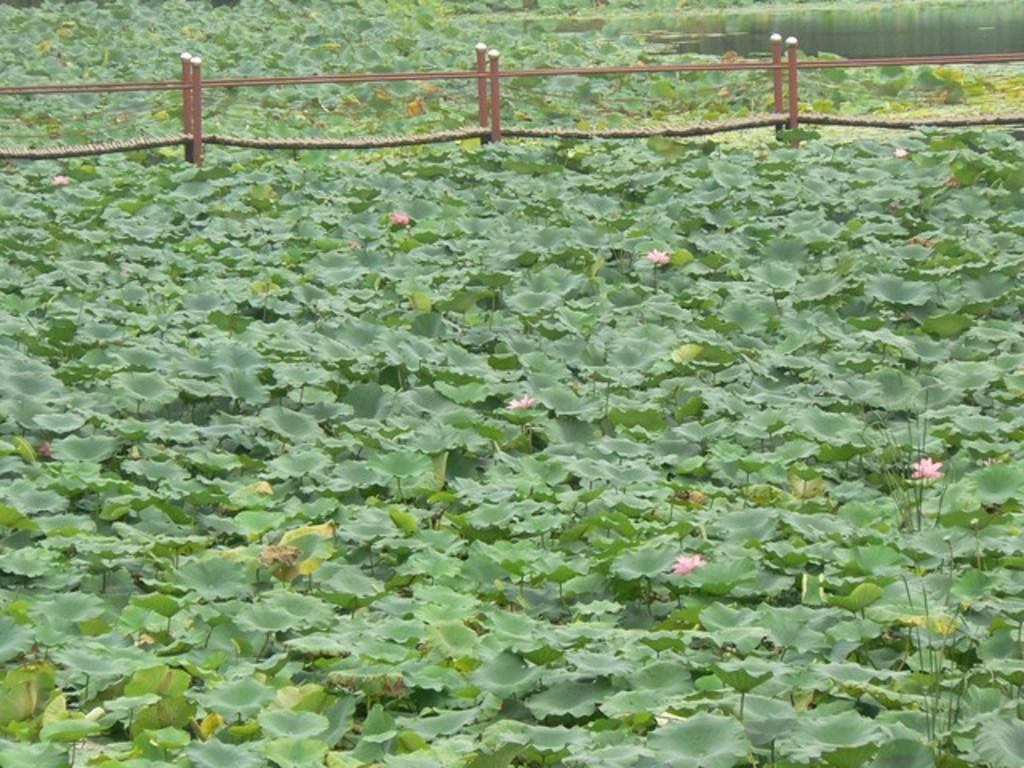What type of living organisms can be seen in the image? Plants and flowers are visible in the image. What structure is present in the image? There is a fence in the image. What natural element can be seen in the image? Water is visible in the image. What type of fork is used to eat the salad in the image? There is no salad or fork present in the image; it features plants, flowers, and a fence. 